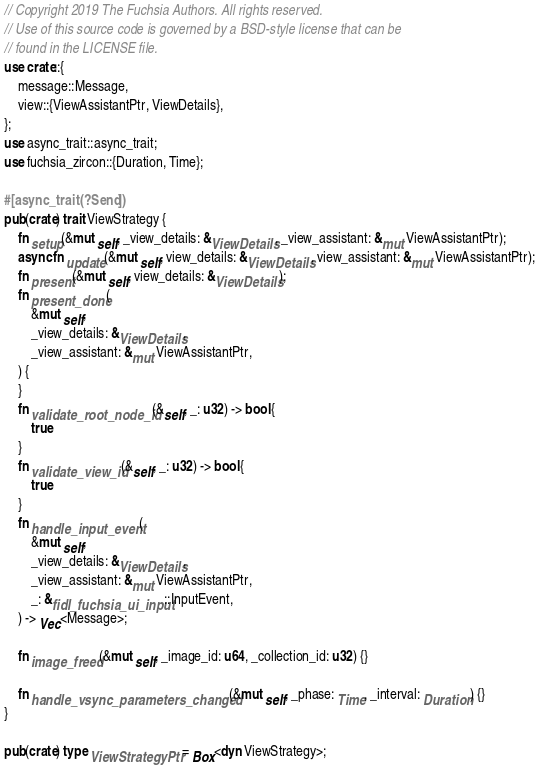<code> <loc_0><loc_0><loc_500><loc_500><_Rust_>// Copyright 2019 The Fuchsia Authors. All rights reserved.
// Use of this source code is governed by a BSD-style license that can be
// found in the LICENSE file.
use crate::{
    message::Message,
    view::{ViewAssistantPtr, ViewDetails},
};
use async_trait::async_trait;
use fuchsia_zircon::{Duration, Time};

#[async_trait(?Send)]
pub(crate) trait ViewStrategy {
    fn setup(&mut self, _view_details: &ViewDetails, _view_assistant: &mut ViewAssistantPtr);
    async fn update(&mut self, view_details: &ViewDetails, view_assistant: &mut ViewAssistantPtr);
    fn present(&mut self, view_details: &ViewDetails);
    fn present_done(
        &mut self,
        _view_details: &ViewDetails,
        _view_assistant: &mut ViewAssistantPtr,
    ) {
    }
    fn validate_root_node_id(&self, _: u32) -> bool {
        true
    }
    fn validate_view_id(&self, _: u32) -> bool {
        true
    }
    fn handle_input_event(
        &mut self,
        _view_details: &ViewDetails,
        _view_assistant: &mut ViewAssistantPtr,
        _: &fidl_fuchsia_ui_input::InputEvent,
    ) -> Vec<Message>;

    fn image_freed(&mut self, _image_id: u64, _collection_id: u32) {}

    fn handle_vsync_parameters_changed(&mut self, _phase: Time, _interval: Duration) {}
}

pub(crate) type ViewStrategyPtr = Box<dyn ViewStrategy>;
</code> 